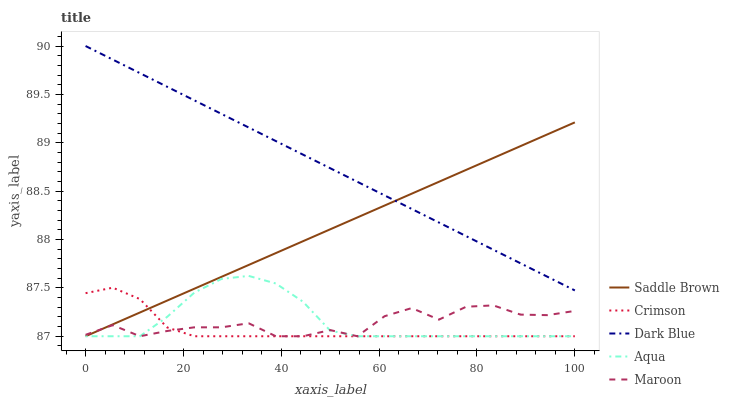Does Crimson have the minimum area under the curve?
Answer yes or no. Yes. Does Dark Blue have the maximum area under the curve?
Answer yes or no. Yes. Does Aqua have the minimum area under the curve?
Answer yes or no. No. Does Aqua have the maximum area under the curve?
Answer yes or no. No. Is Saddle Brown the smoothest?
Answer yes or no. Yes. Is Maroon the roughest?
Answer yes or no. Yes. Is Dark Blue the smoothest?
Answer yes or no. No. Is Dark Blue the roughest?
Answer yes or no. No. Does Crimson have the lowest value?
Answer yes or no. Yes. Does Dark Blue have the lowest value?
Answer yes or no. No. Does Dark Blue have the highest value?
Answer yes or no. Yes. Does Aqua have the highest value?
Answer yes or no. No. Is Maroon less than Dark Blue?
Answer yes or no. Yes. Is Dark Blue greater than Aqua?
Answer yes or no. Yes. Does Maroon intersect Saddle Brown?
Answer yes or no. Yes. Is Maroon less than Saddle Brown?
Answer yes or no. No. Is Maroon greater than Saddle Brown?
Answer yes or no. No. Does Maroon intersect Dark Blue?
Answer yes or no. No. 